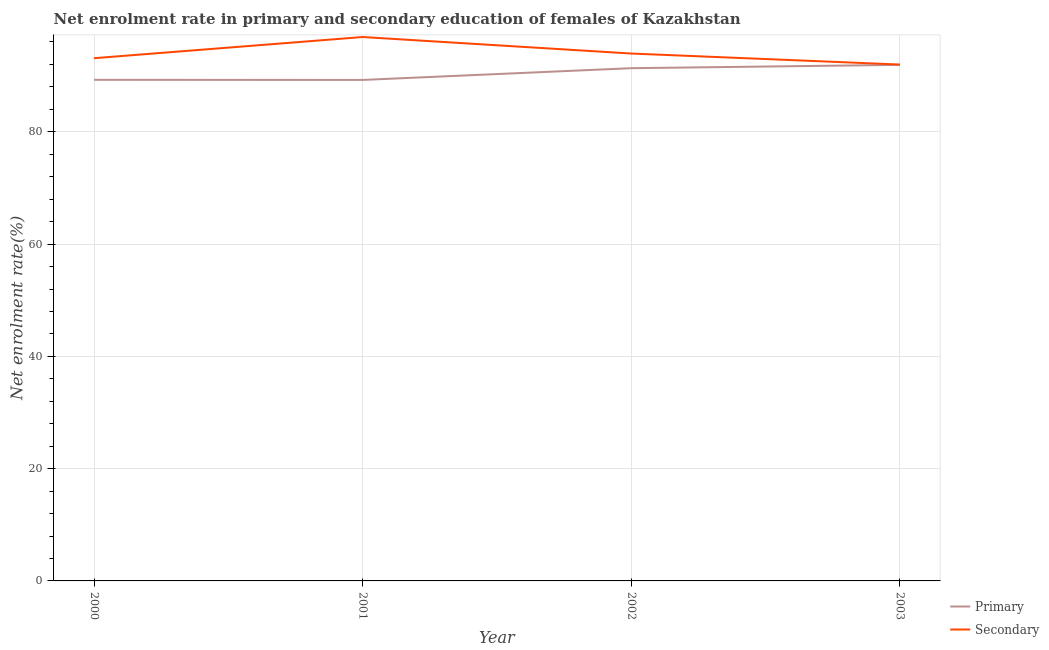How many different coloured lines are there?
Offer a very short reply. 2. What is the enrollment rate in primary education in 2001?
Your answer should be very brief. 89.24. Across all years, what is the maximum enrollment rate in primary education?
Give a very brief answer. 91.92. Across all years, what is the minimum enrollment rate in secondary education?
Your answer should be very brief. 91.98. In which year was the enrollment rate in primary education minimum?
Give a very brief answer. 2001. What is the total enrollment rate in primary education in the graph?
Your response must be concise. 361.76. What is the difference between the enrollment rate in secondary education in 2002 and that in 2003?
Give a very brief answer. 1.96. What is the difference between the enrollment rate in secondary education in 2003 and the enrollment rate in primary education in 2001?
Provide a short and direct response. 2.74. What is the average enrollment rate in secondary education per year?
Give a very brief answer. 93.98. In the year 2000, what is the difference between the enrollment rate in primary education and enrollment rate in secondary education?
Provide a short and direct response. -3.85. In how many years, is the enrollment rate in primary education greater than 24 %?
Offer a terse response. 4. What is the ratio of the enrollment rate in primary education in 2002 to that in 2003?
Ensure brevity in your answer.  0.99. Is the enrollment rate in primary education in 2001 less than that in 2003?
Provide a succinct answer. Yes. What is the difference between the highest and the second highest enrollment rate in primary education?
Your answer should be compact. 0.59. What is the difference between the highest and the lowest enrollment rate in primary education?
Ensure brevity in your answer.  2.68. Is the sum of the enrollment rate in secondary education in 2000 and 2002 greater than the maximum enrollment rate in primary education across all years?
Give a very brief answer. Yes. Does the enrollment rate in primary education monotonically increase over the years?
Keep it short and to the point. No. Is the enrollment rate in primary education strictly greater than the enrollment rate in secondary education over the years?
Give a very brief answer. No. Is the enrollment rate in primary education strictly less than the enrollment rate in secondary education over the years?
Your response must be concise. Yes. How many years are there in the graph?
Offer a terse response. 4. Does the graph contain any zero values?
Make the answer very short. No. Where does the legend appear in the graph?
Your answer should be compact. Bottom right. How many legend labels are there?
Your response must be concise. 2. What is the title of the graph?
Offer a terse response. Net enrolment rate in primary and secondary education of females of Kazakhstan. What is the label or title of the Y-axis?
Give a very brief answer. Net enrolment rate(%). What is the Net enrolment rate(%) of Primary in 2000?
Offer a very short reply. 89.26. What is the Net enrolment rate(%) of Secondary in 2000?
Offer a very short reply. 93.11. What is the Net enrolment rate(%) of Primary in 2001?
Offer a terse response. 89.24. What is the Net enrolment rate(%) of Secondary in 2001?
Make the answer very short. 96.89. What is the Net enrolment rate(%) of Primary in 2002?
Give a very brief answer. 91.33. What is the Net enrolment rate(%) in Secondary in 2002?
Your answer should be compact. 93.94. What is the Net enrolment rate(%) in Primary in 2003?
Your answer should be very brief. 91.92. What is the Net enrolment rate(%) in Secondary in 2003?
Provide a short and direct response. 91.98. Across all years, what is the maximum Net enrolment rate(%) of Primary?
Ensure brevity in your answer.  91.92. Across all years, what is the maximum Net enrolment rate(%) in Secondary?
Offer a very short reply. 96.89. Across all years, what is the minimum Net enrolment rate(%) of Primary?
Your answer should be compact. 89.24. Across all years, what is the minimum Net enrolment rate(%) of Secondary?
Give a very brief answer. 91.98. What is the total Net enrolment rate(%) of Primary in the graph?
Give a very brief answer. 361.76. What is the total Net enrolment rate(%) in Secondary in the graph?
Keep it short and to the point. 375.93. What is the difference between the Net enrolment rate(%) of Primary in 2000 and that in 2001?
Your answer should be very brief. 0.02. What is the difference between the Net enrolment rate(%) of Secondary in 2000 and that in 2001?
Ensure brevity in your answer.  -3.77. What is the difference between the Net enrolment rate(%) in Primary in 2000 and that in 2002?
Ensure brevity in your answer.  -2.07. What is the difference between the Net enrolment rate(%) in Secondary in 2000 and that in 2002?
Give a very brief answer. -0.83. What is the difference between the Net enrolment rate(%) in Primary in 2000 and that in 2003?
Provide a short and direct response. -2.66. What is the difference between the Net enrolment rate(%) in Secondary in 2000 and that in 2003?
Your answer should be compact. 1.13. What is the difference between the Net enrolment rate(%) in Primary in 2001 and that in 2002?
Offer a very short reply. -2.09. What is the difference between the Net enrolment rate(%) in Secondary in 2001 and that in 2002?
Keep it short and to the point. 2.94. What is the difference between the Net enrolment rate(%) of Primary in 2001 and that in 2003?
Your answer should be compact. -2.68. What is the difference between the Net enrolment rate(%) of Secondary in 2001 and that in 2003?
Your response must be concise. 4.9. What is the difference between the Net enrolment rate(%) in Primary in 2002 and that in 2003?
Provide a succinct answer. -0.59. What is the difference between the Net enrolment rate(%) of Secondary in 2002 and that in 2003?
Offer a very short reply. 1.96. What is the difference between the Net enrolment rate(%) of Primary in 2000 and the Net enrolment rate(%) of Secondary in 2001?
Provide a succinct answer. -7.62. What is the difference between the Net enrolment rate(%) in Primary in 2000 and the Net enrolment rate(%) in Secondary in 2002?
Your answer should be compact. -4.68. What is the difference between the Net enrolment rate(%) of Primary in 2000 and the Net enrolment rate(%) of Secondary in 2003?
Provide a succinct answer. -2.72. What is the difference between the Net enrolment rate(%) of Primary in 2001 and the Net enrolment rate(%) of Secondary in 2002?
Make the answer very short. -4.7. What is the difference between the Net enrolment rate(%) of Primary in 2001 and the Net enrolment rate(%) of Secondary in 2003?
Your answer should be compact. -2.74. What is the difference between the Net enrolment rate(%) of Primary in 2002 and the Net enrolment rate(%) of Secondary in 2003?
Your answer should be compact. -0.65. What is the average Net enrolment rate(%) in Primary per year?
Your response must be concise. 90.44. What is the average Net enrolment rate(%) in Secondary per year?
Ensure brevity in your answer.  93.98. In the year 2000, what is the difference between the Net enrolment rate(%) in Primary and Net enrolment rate(%) in Secondary?
Provide a succinct answer. -3.85. In the year 2001, what is the difference between the Net enrolment rate(%) in Primary and Net enrolment rate(%) in Secondary?
Your answer should be very brief. -7.64. In the year 2002, what is the difference between the Net enrolment rate(%) of Primary and Net enrolment rate(%) of Secondary?
Provide a short and direct response. -2.61. In the year 2003, what is the difference between the Net enrolment rate(%) in Primary and Net enrolment rate(%) in Secondary?
Offer a very short reply. -0.06. What is the ratio of the Net enrolment rate(%) in Primary in 2000 to that in 2001?
Provide a succinct answer. 1. What is the ratio of the Net enrolment rate(%) of Secondary in 2000 to that in 2001?
Your answer should be compact. 0.96. What is the ratio of the Net enrolment rate(%) of Primary in 2000 to that in 2002?
Your response must be concise. 0.98. What is the ratio of the Net enrolment rate(%) of Primary in 2000 to that in 2003?
Offer a terse response. 0.97. What is the ratio of the Net enrolment rate(%) of Secondary in 2000 to that in 2003?
Make the answer very short. 1.01. What is the ratio of the Net enrolment rate(%) in Primary in 2001 to that in 2002?
Provide a short and direct response. 0.98. What is the ratio of the Net enrolment rate(%) in Secondary in 2001 to that in 2002?
Keep it short and to the point. 1.03. What is the ratio of the Net enrolment rate(%) of Primary in 2001 to that in 2003?
Ensure brevity in your answer.  0.97. What is the ratio of the Net enrolment rate(%) of Secondary in 2001 to that in 2003?
Ensure brevity in your answer.  1.05. What is the ratio of the Net enrolment rate(%) of Secondary in 2002 to that in 2003?
Keep it short and to the point. 1.02. What is the difference between the highest and the second highest Net enrolment rate(%) of Primary?
Ensure brevity in your answer.  0.59. What is the difference between the highest and the second highest Net enrolment rate(%) of Secondary?
Provide a short and direct response. 2.94. What is the difference between the highest and the lowest Net enrolment rate(%) of Primary?
Make the answer very short. 2.68. What is the difference between the highest and the lowest Net enrolment rate(%) of Secondary?
Ensure brevity in your answer.  4.9. 